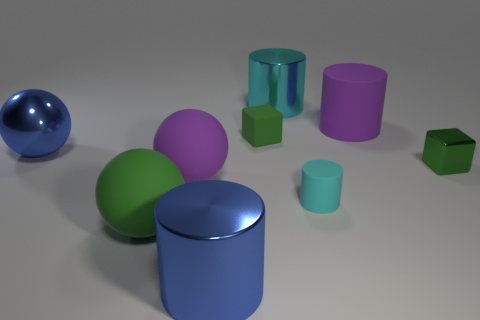Subtract 1 cylinders. How many cylinders are left? 3 Add 1 tiny matte cylinders. How many objects exist? 10 Subtract all balls. How many objects are left? 6 Subtract 0 red cubes. How many objects are left? 9 Subtract all tiny rubber cubes. Subtract all small gray shiny cylinders. How many objects are left? 8 Add 2 small cyan things. How many small cyan things are left? 3 Add 3 big gray spheres. How many big gray spheres exist? 3 